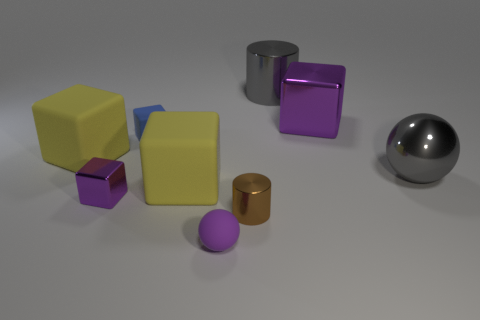Are there fewer gray cylinders that are in front of the small metallic cube than green metallic things? After analyzing the image, there is only one gray cylinder present, which is indeed in front of the small metallic cube. Comparing this to the green metallic objects, there is only one green metallic object visible. Therefore, the number of gray cylinders in front of the small metallic cube is not less than the number of green metallic things. 